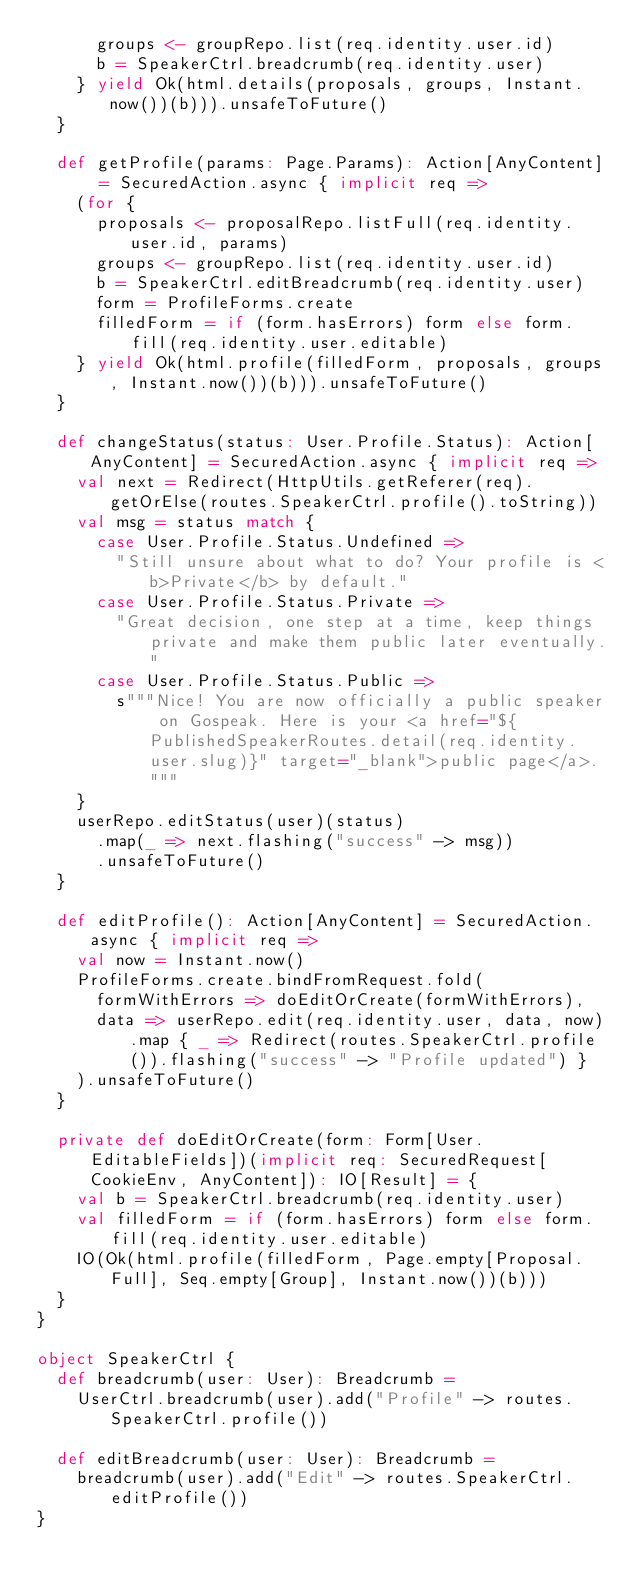Convert code to text. <code><loc_0><loc_0><loc_500><loc_500><_Scala_>      groups <- groupRepo.list(req.identity.user.id)
      b = SpeakerCtrl.breadcrumb(req.identity.user)
    } yield Ok(html.details(proposals, groups, Instant.now())(b))).unsafeToFuture()
  }

  def getProfile(params: Page.Params): Action[AnyContent] = SecuredAction.async { implicit req =>
    (for {
      proposals <- proposalRepo.listFull(req.identity.user.id, params)
      groups <- groupRepo.list(req.identity.user.id)
      b = SpeakerCtrl.editBreadcrumb(req.identity.user)
      form = ProfileForms.create
      filledForm = if (form.hasErrors) form else form.fill(req.identity.user.editable)
    } yield Ok(html.profile(filledForm, proposals, groups, Instant.now())(b))).unsafeToFuture()
  }

  def changeStatus(status: User.Profile.Status): Action[AnyContent] = SecuredAction.async { implicit req =>
    val next = Redirect(HttpUtils.getReferer(req).getOrElse(routes.SpeakerCtrl.profile().toString))
    val msg = status match {
      case User.Profile.Status.Undefined =>
        "Still unsure about what to do? Your profile is <b>Private</b> by default."
      case User.Profile.Status.Private =>
        "Great decision, one step at a time, keep things private and make them public later eventually."
      case User.Profile.Status.Public =>
        s"""Nice! You are now officially a public speaker on Gospeak. Here is your <a href="${PublishedSpeakerRoutes.detail(req.identity.user.slug)}" target="_blank">public page</a>."""
    }
    userRepo.editStatus(user)(status)
      .map(_ => next.flashing("success" -> msg))
      .unsafeToFuture()
  }

  def editProfile(): Action[AnyContent] = SecuredAction.async { implicit req =>
    val now = Instant.now()
    ProfileForms.create.bindFromRequest.fold(
      formWithErrors => doEditOrCreate(formWithErrors),
      data => userRepo.edit(req.identity.user, data, now).map { _ => Redirect(routes.SpeakerCtrl.profile()).flashing("success" -> "Profile updated") }
    ).unsafeToFuture()
  }

  private def doEditOrCreate(form: Form[User.EditableFields])(implicit req: SecuredRequest[CookieEnv, AnyContent]): IO[Result] = {
    val b = SpeakerCtrl.breadcrumb(req.identity.user)
    val filledForm = if (form.hasErrors) form else form.fill(req.identity.user.editable)
    IO(Ok(html.profile(filledForm, Page.empty[Proposal.Full], Seq.empty[Group], Instant.now())(b)))
  }
}

object SpeakerCtrl {
  def breadcrumb(user: User): Breadcrumb =
    UserCtrl.breadcrumb(user).add("Profile" -> routes.SpeakerCtrl.profile())

  def editBreadcrumb(user: User): Breadcrumb =
    breadcrumb(user).add("Edit" -> routes.SpeakerCtrl.editProfile())
}
</code> 